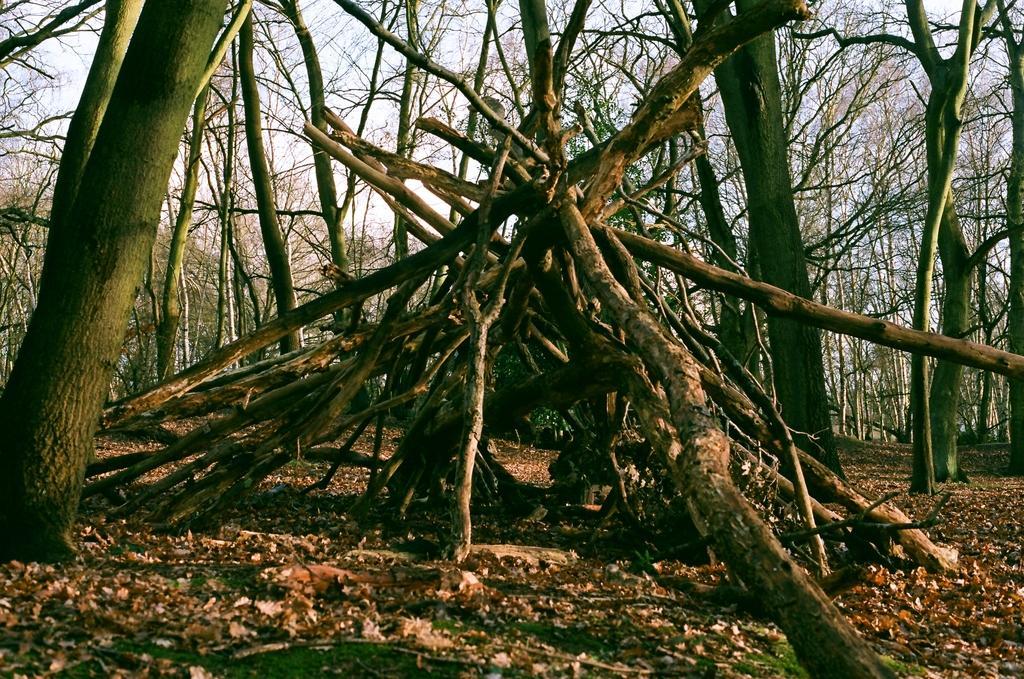In one or two sentences, can you explain what this image depicts? In the picture we can see a group of sticks which are placed on the path, the path is with full of dried leaves and mud and in the background we can see dried trees and a part of the sky. 